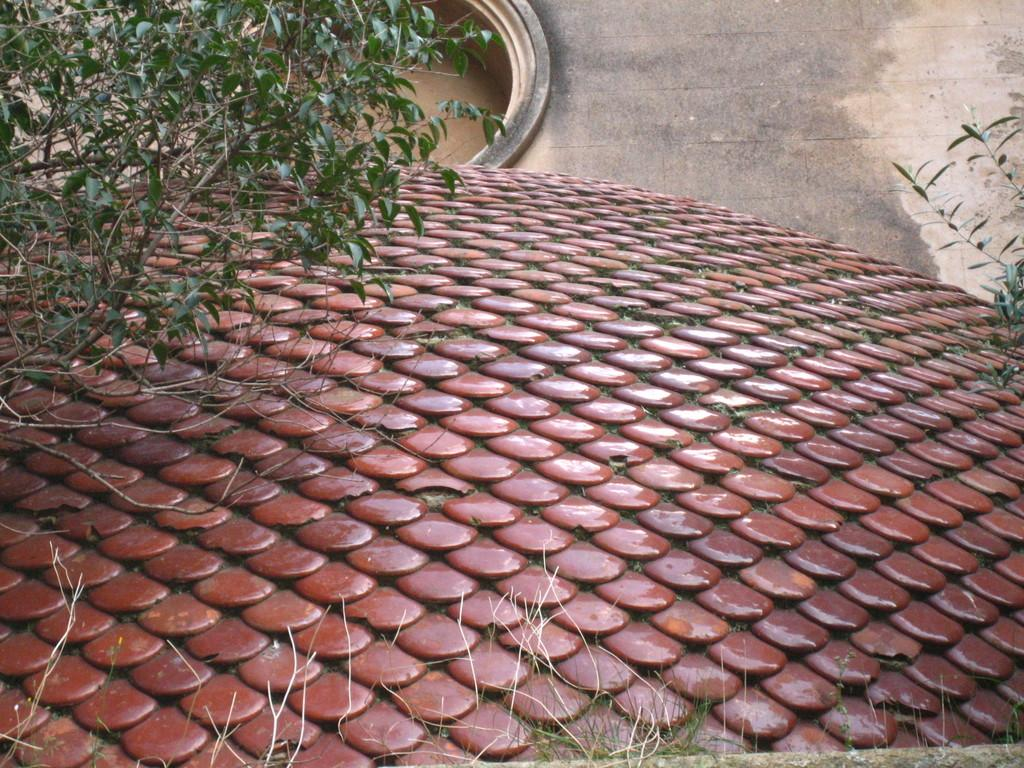What type of vegetation can be seen in the image? There is grass in the image. What else can be seen in the image besides the grass? There is a design, plants, a platform, and an object in the image. Can you describe the design in the image? Unfortunately, the facts provided do not give enough information to describe the design in detail. What is the platform used for in the image? The facts provided do not give enough information to determine the purpose of the platform. How many goldfish are swimming in the grass in the image? There are no goldfish present in the image; it features grass, a design, plants, a platform, and an object. 